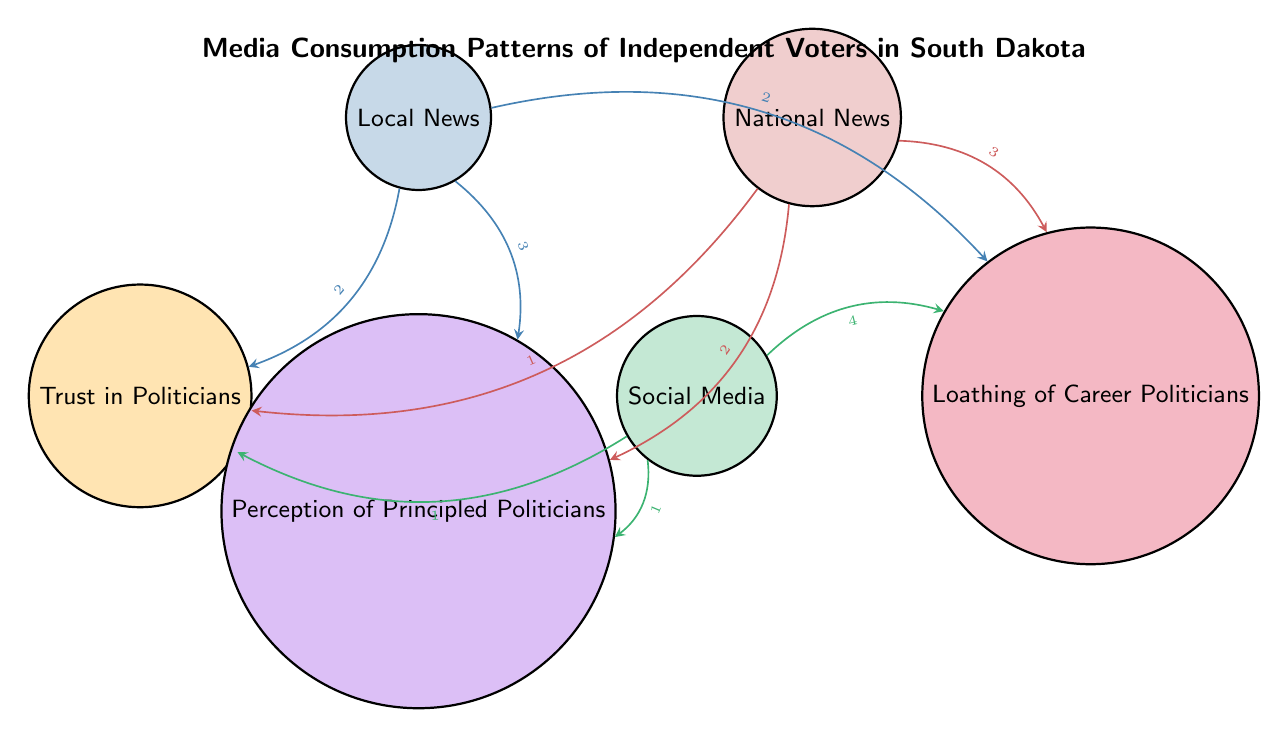What is the value of the link between Local News and Trust in Politicians? The diagram shows a link from Local News to Trust in Politicians with a value of 2, indicated by the label on the connecting arrow.
Answer: 2 What media outlet has the strongest influence on Loathing of Career Politicians? The diagram indicates that Social Media has the highest value (4) for the link to Loathing of Career Politicians compared to Local News (2) and National News (3).
Answer: Social Media How many edges are connected to the node Perception of Principled Politicians? The counts of edges connected to Perception of Principled Politicians are three: one from Local News, one from National News, and one from Social Media.
Answer: 3 Which media outlet influences Trust in Politicians the least? By comparing the values, National News (1) and Social Media (1) have the lowest influence on Trust in Politicians, tied for the least, but only one can be chosen as it's phrased.
Answer: National News What is the total value of links from Local News? The links from Local News add up as follows: 2 (Trust in Politicians) + 3 (Perception of Principled Politicians) + 2 (Loathing of Career Politicians) = 7.
Answer: 7 Which type of media outlet has the highest link value to Perception of Principled Politicians? The diagram shows that Local News has the strongest link (3) to Perception of Principled Politicians when compared to National News (2) and Social Media (1).
Answer: Local News If Trust in Politicians were to be influenced by just one media outlet, which would be the best choice? The Local News has the highest value (2) for its link to Trust in Politicians compared to both National News (1) and Social Media (1), making it the strongest influencer.
Answer: Local News How many total nodes are in the diagram? The nodes listed are Local News, National News, Social Media, Trust in Politicians, Perception of Principled Politicians, and Loathing of Career Politicians, so there are 6 nodes total.
Answer: 6 